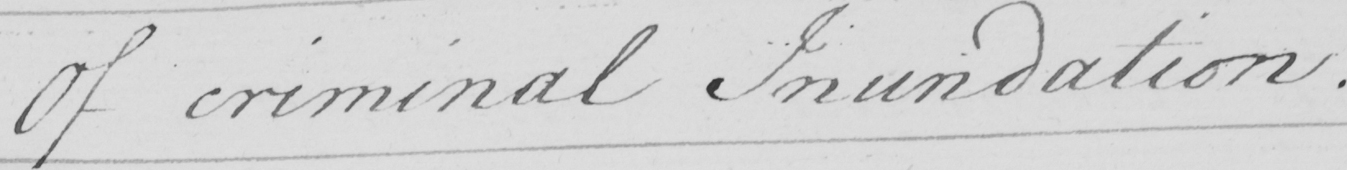Can you read and transcribe this handwriting? Of criminal Inundation . 